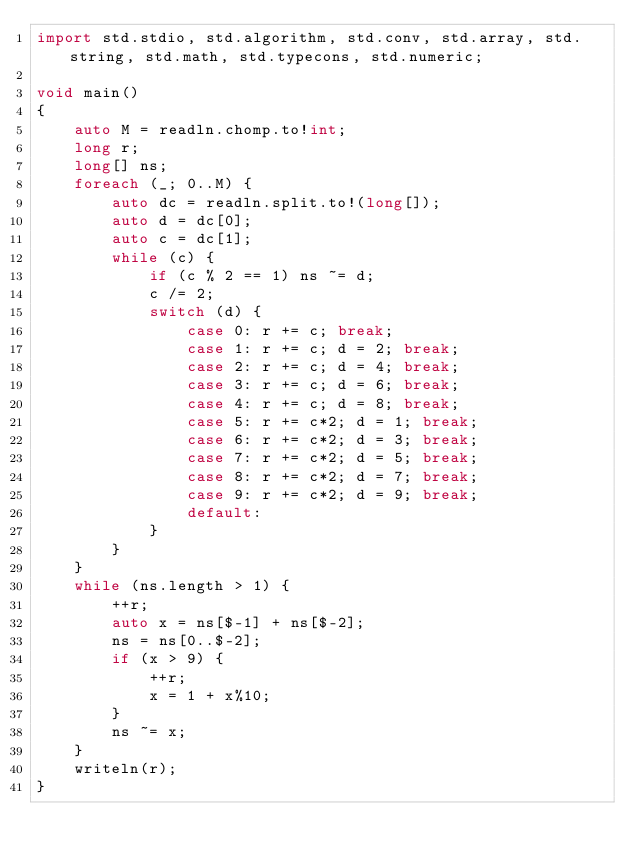<code> <loc_0><loc_0><loc_500><loc_500><_D_>import std.stdio, std.algorithm, std.conv, std.array, std.string, std.math, std.typecons, std.numeric;

void main()
{
    auto M = readln.chomp.to!int;
    long r;
    long[] ns;
    foreach (_; 0..M) {
        auto dc = readln.split.to!(long[]);
        auto d = dc[0];
        auto c = dc[1];
        while (c) {
            if (c % 2 == 1) ns ~= d;
            c /= 2;
            switch (d) {
                case 0: r += c; break;
                case 1: r += c; d = 2; break;
                case 2: r += c; d = 4; break;
                case 3: r += c; d = 6; break;
                case 4: r += c; d = 8; break;
                case 5: r += c*2; d = 1; break;
                case 6: r += c*2; d = 3; break;
                case 7: r += c*2; d = 5; break;
                case 8: r += c*2; d = 7; break;
                case 9: r += c*2; d = 9; break;
                default:
            }
        }
    }
    while (ns.length > 1) {
        ++r;
        auto x = ns[$-1] + ns[$-2];
        ns = ns[0..$-2];
        if (x > 9) {
            ++r;
            x = 1 + x%10;
        }
        ns ~= x;
    }
    writeln(r);
}</code> 